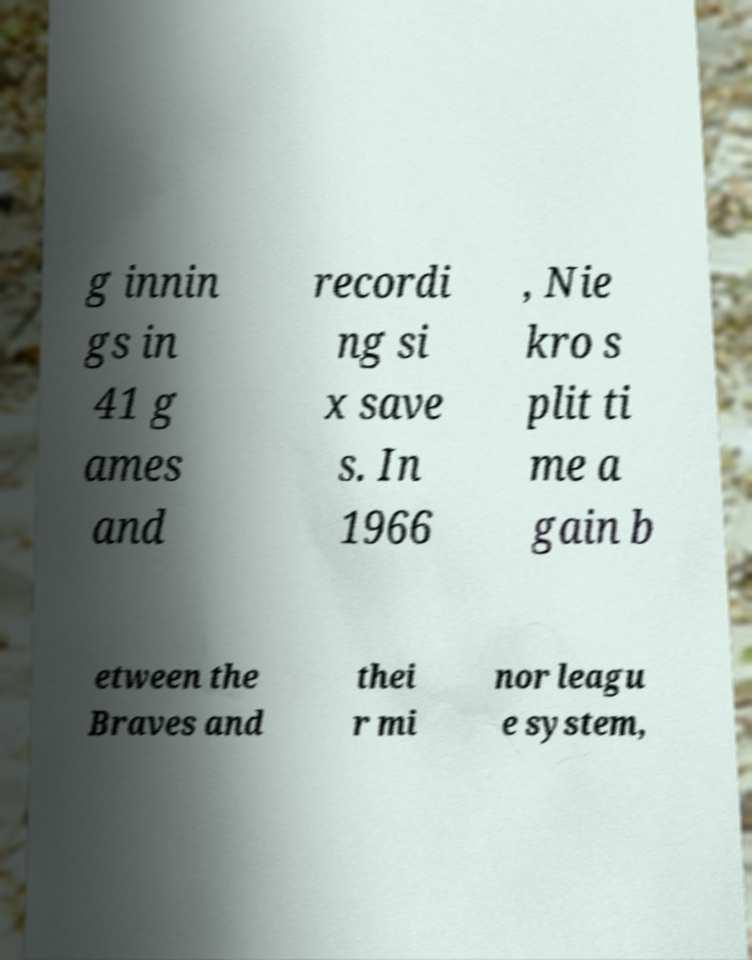There's text embedded in this image that I need extracted. Can you transcribe it verbatim? g innin gs in 41 g ames and recordi ng si x save s. In 1966 , Nie kro s plit ti me a gain b etween the Braves and thei r mi nor leagu e system, 